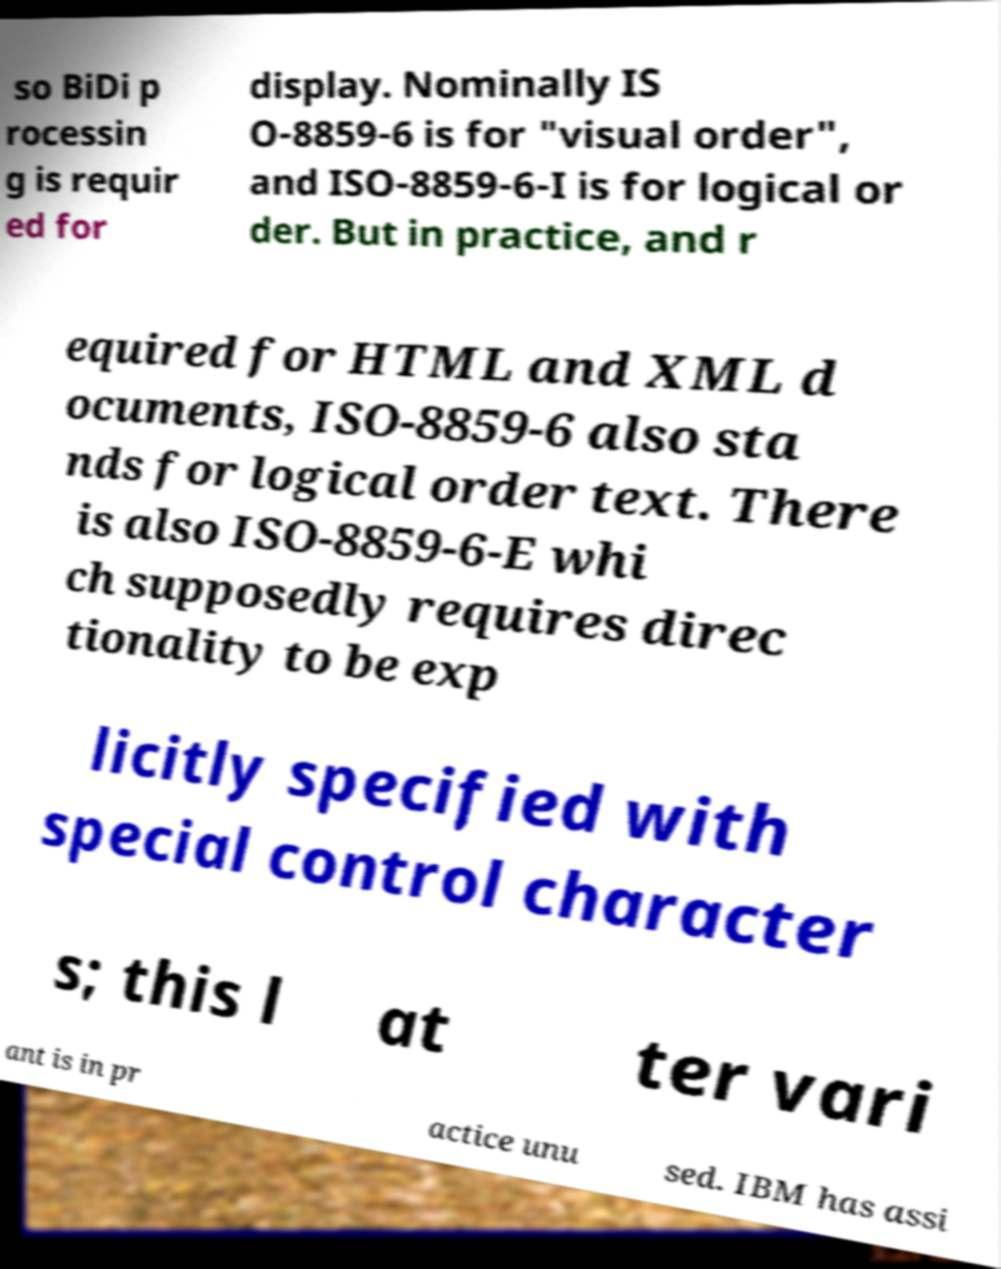Please read and relay the text visible in this image. What does it say? so BiDi p rocessin g is requir ed for display. Nominally IS O-8859-6 is for "visual order", and ISO-8859-6-I is for logical or der. But in practice, and r equired for HTML and XML d ocuments, ISO-8859-6 also sta nds for logical order text. There is also ISO-8859-6-E whi ch supposedly requires direc tionality to be exp licitly specified with special control character s; this l at ter vari ant is in pr actice unu sed. IBM has assi 